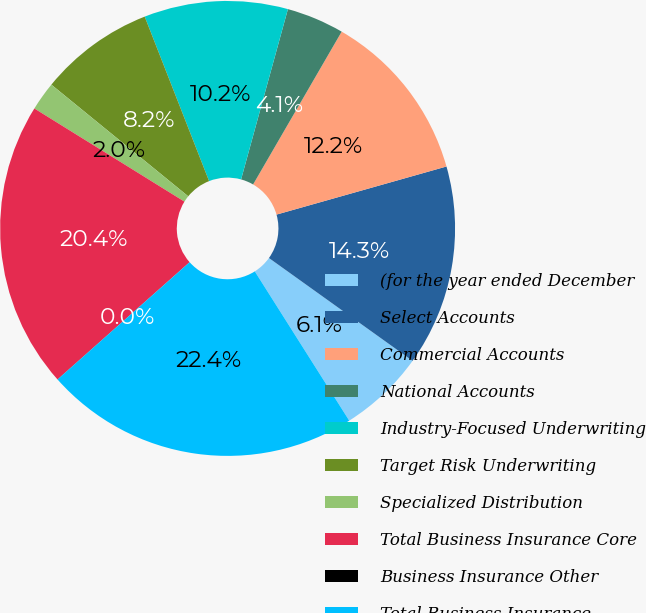Convert chart to OTSL. <chart><loc_0><loc_0><loc_500><loc_500><pie_chart><fcel>(for the year ended December<fcel>Select Accounts<fcel>Commercial Accounts<fcel>National Accounts<fcel>Industry-Focused Underwriting<fcel>Target Risk Underwriting<fcel>Specialized Distribution<fcel>Total Business Insurance Core<fcel>Business Insurance Other<fcel>Total Business Insurance<nl><fcel>6.13%<fcel>14.28%<fcel>12.25%<fcel>4.09%<fcel>10.21%<fcel>8.17%<fcel>2.05%<fcel>20.39%<fcel>0.01%<fcel>22.42%<nl></chart> 